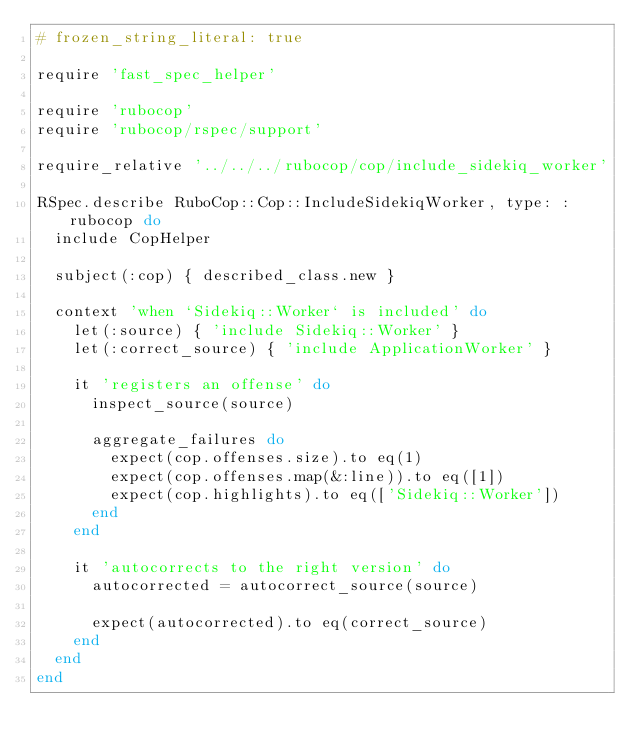<code> <loc_0><loc_0><loc_500><loc_500><_Ruby_># frozen_string_literal: true

require 'fast_spec_helper'

require 'rubocop'
require 'rubocop/rspec/support'

require_relative '../../../rubocop/cop/include_sidekiq_worker'

RSpec.describe RuboCop::Cop::IncludeSidekiqWorker, type: :rubocop do
  include CopHelper

  subject(:cop) { described_class.new }

  context 'when `Sidekiq::Worker` is included' do
    let(:source) { 'include Sidekiq::Worker' }
    let(:correct_source) { 'include ApplicationWorker' }

    it 'registers an offense' do
      inspect_source(source)

      aggregate_failures do
        expect(cop.offenses.size).to eq(1)
        expect(cop.offenses.map(&:line)).to eq([1])
        expect(cop.highlights).to eq(['Sidekiq::Worker'])
      end
    end

    it 'autocorrects to the right version' do
      autocorrected = autocorrect_source(source)

      expect(autocorrected).to eq(correct_source)
    end
  end
end
</code> 